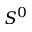Convert formula to latex. <formula><loc_0><loc_0><loc_500><loc_500>S ^ { 0 }</formula> 